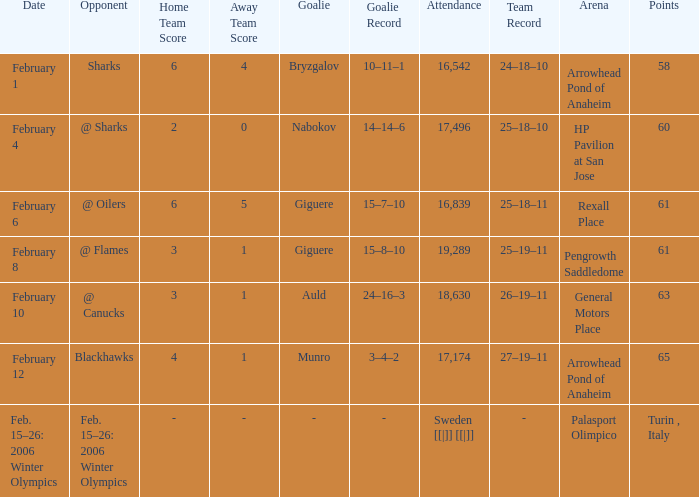What were the marks on february 10? 63.0. 